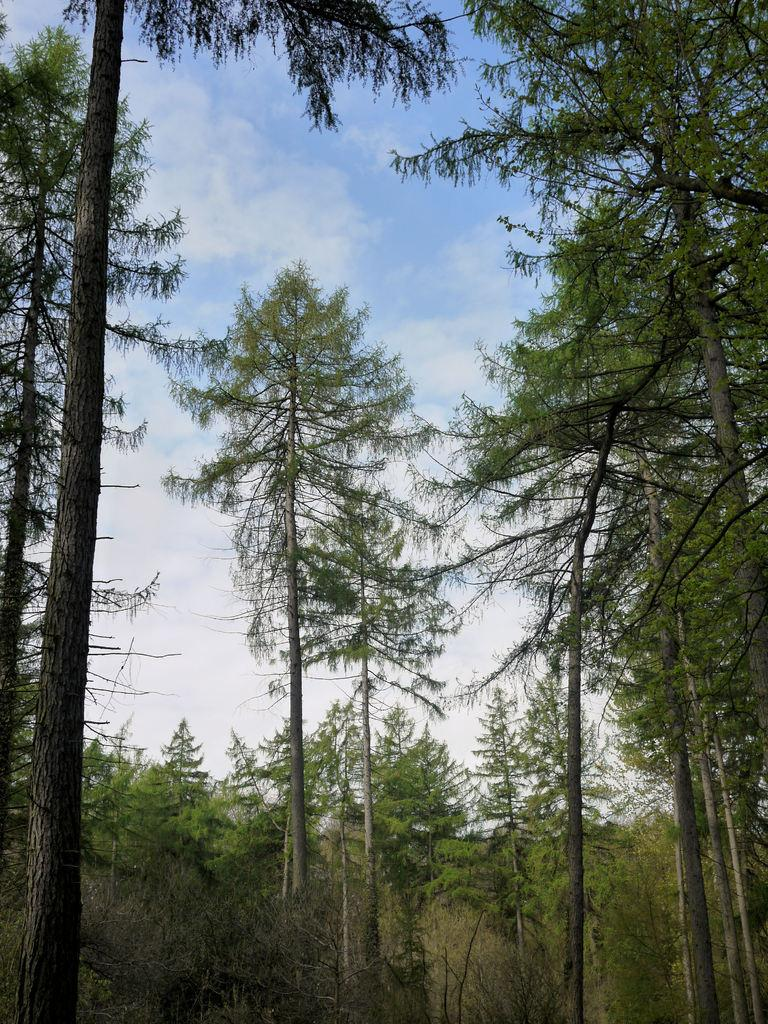What type of vegetation can be seen in the image? There are trees in the image. What colors are the trees in the image? The trees have different colors: green, black, and ash. What is visible in the background of the image? The sky is visible in the background of the image. Are there any beds visible in the image? There are no beds present in the image; it features trees and the sky. Can you see any masks on the trees in the image? There are no masks present on the trees in the image; the trees have different colors: green, black, and ash. 